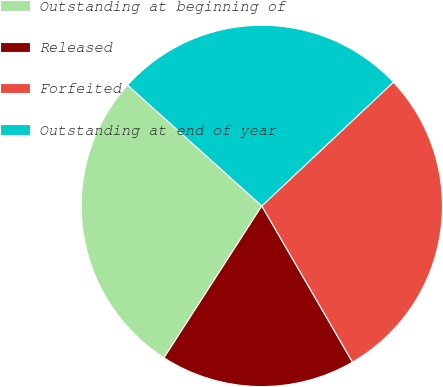Convert chart. <chart><loc_0><loc_0><loc_500><loc_500><pie_chart><fcel>Outstanding at beginning of<fcel>Released<fcel>Forfeited<fcel>Outstanding at end of year<nl><fcel>27.55%<fcel>17.48%<fcel>28.64%<fcel>26.32%<nl></chart> 